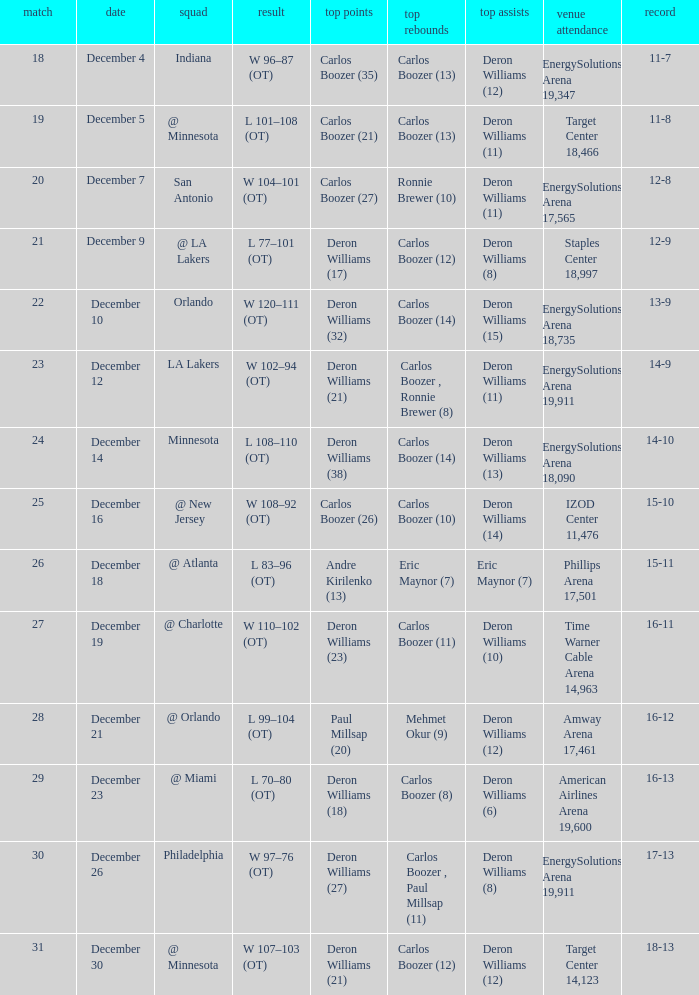When was the game in which Deron Williams (13) did the high assists played? December 14. 